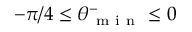Convert formula to latex. <formula><loc_0><loc_0><loc_500><loc_500>- \pi / 4 \leq \theta _ { m i n } ^ { - } \leq 0</formula> 